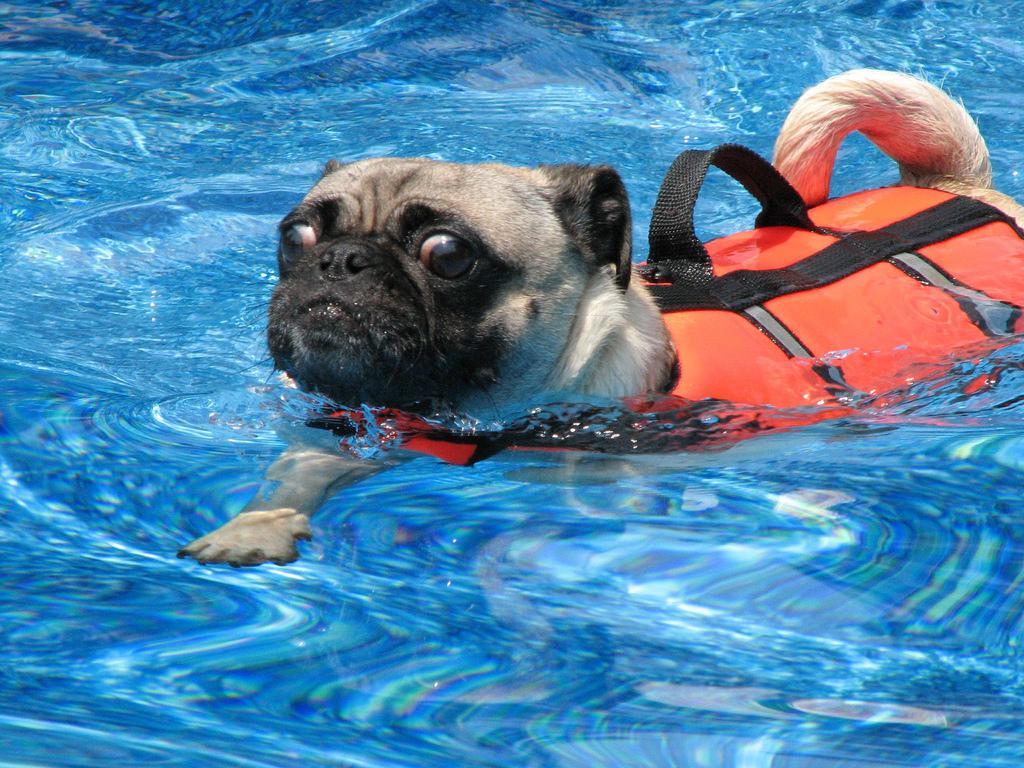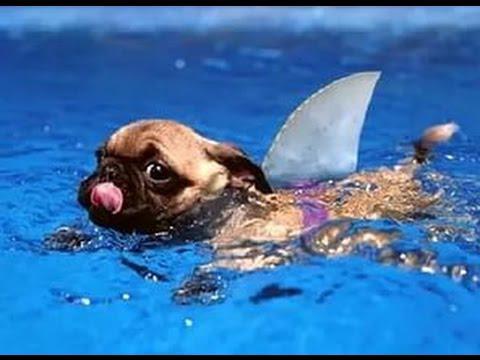The first image is the image on the left, the second image is the image on the right. Given the left and right images, does the statement "In one image a pug dog is swimming in a pool while wearing a green life jacket." hold true? Answer yes or no. No. 